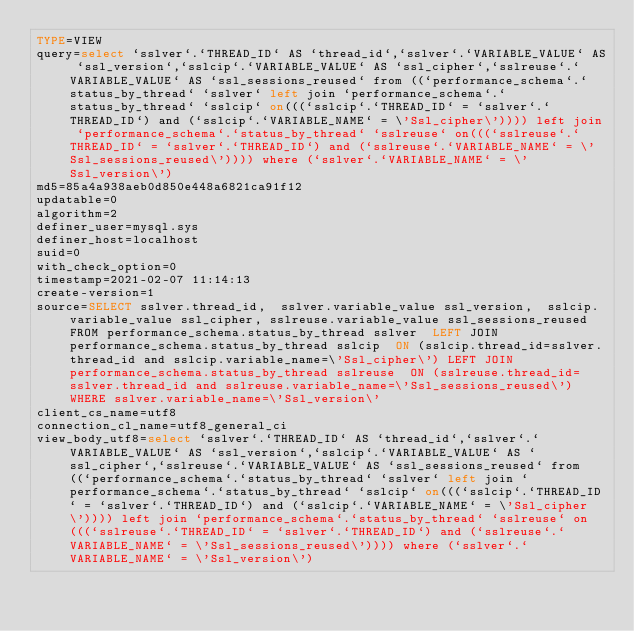Convert code to text. <code><loc_0><loc_0><loc_500><loc_500><_VisualBasic_>TYPE=VIEW
query=select `sslver`.`THREAD_ID` AS `thread_id`,`sslver`.`VARIABLE_VALUE` AS `ssl_version`,`sslcip`.`VARIABLE_VALUE` AS `ssl_cipher`,`sslreuse`.`VARIABLE_VALUE` AS `ssl_sessions_reused` from ((`performance_schema`.`status_by_thread` `sslver` left join `performance_schema`.`status_by_thread` `sslcip` on(((`sslcip`.`THREAD_ID` = `sslver`.`THREAD_ID`) and (`sslcip`.`VARIABLE_NAME` = \'Ssl_cipher\')))) left join `performance_schema`.`status_by_thread` `sslreuse` on(((`sslreuse`.`THREAD_ID` = `sslver`.`THREAD_ID`) and (`sslreuse`.`VARIABLE_NAME` = \'Ssl_sessions_reused\')))) where (`sslver`.`VARIABLE_NAME` = \'Ssl_version\')
md5=85a4a938aeb0d850e448a6821ca91f12
updatable=0
algorithm=2
definer_user=mysql.sys
definer_host=localhost
suid=0
with_check_option=0
timestamp=2021-02-07 11:14:13
create-version=1
source=SELECT sslver.thread_id,  sslver.variable_value ssl_version,  sslcip.variable_value ssl_cipher, sslreuse.variable_value ssl_sessions_reused FROM performance_schema.status_by_thread sslver  LEFT JOIN performance_schema.status_by_thread sslcip  ON (sslcip.thread_id=sslver.thread_id and sslcip.variable_name=\'Ssl_cipher\') LEFT JOIN performance_schema.status_by_thread sslreuse  ON (sslreuse.thread_id=sslver.thread_id and sslreuse.variable_name=\'Ssl_sessions_reused\')  WHERE sslver.variable_name=\'Ssl_version\'
client_cs_name=utf8
connection_cl_name=utf8_general_ci
view_body_utf8=select `sslver`.`THREAD_ID` AS `thread_id`,`sslver`.`VARIABLE_VALUE` AS `ssl_version`,`sslcip`.`VARIABLE_VALUE` AS `ssl_cipher`,`sslreuse`.`VARIABLE_VALUE` AS `ssl_sessions_reused` from ((`performance_schema`.`status_by_thread` `sslver` left join `performance_schema`.`status_by_thread` `sslcip` on(((`sslcip`.`THREAD_ID` = `sslver`.`THREAD_ID`) and (`sslcip`.`VARIABLE_NAME` = \'Ssl_cipher\')))) left join `performance_schema`.`status_by_thread` `sslreuse` on(((`sslreuse`.`THREAD_ID` = `sslver`.`THREAD_ID`) and (`sslreuse`.`VARIABLE_NAME` = \'Ssl_sessions_reused\')))) where (`sslver`.`VARIABLE_NAME` = \'Ssl_version\')
</code> 